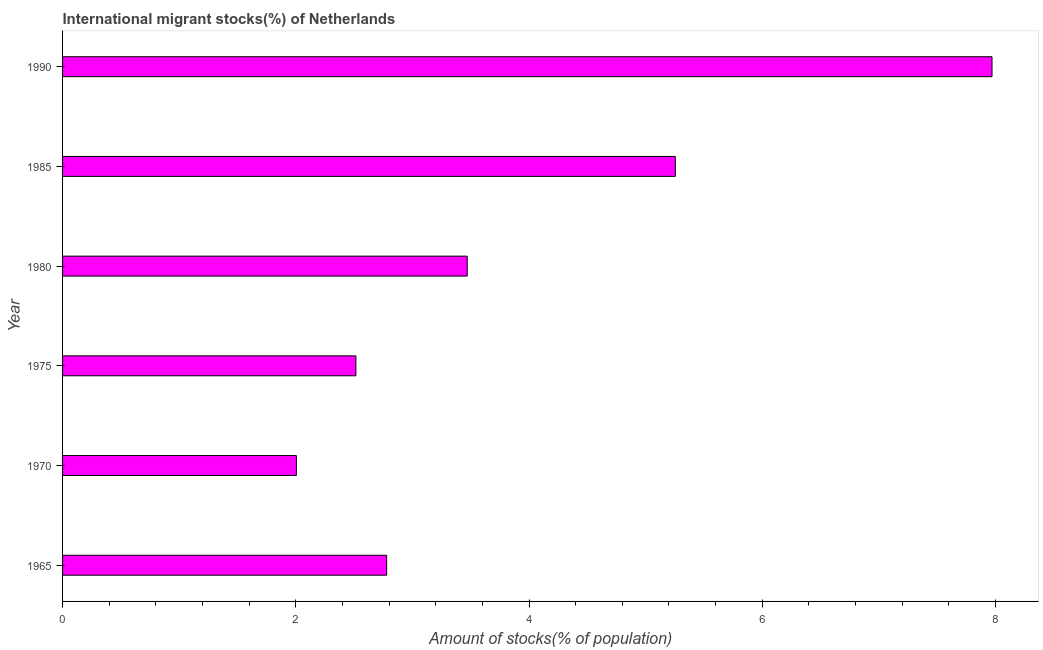Does the graph contain any zero values?
Provide a short and direct response. No. What is the title of the graph?
Make the answer very short. International migrant stocks(%) of Netherlands. What is the label or title of the X-axis?
Keep it short and to the point. Amount of stocks(% of population). What is the label or title of the Y-axis?
Ensure brevity in your answer.  Year. What is the number of international migrant stocks in 1980?
Your answer should be very brief. 3.47. Across all years, what is the maximum number of international migrant stocks?
Provide a succinct answer. 7.97. Across all years, what is the minimum number of international migrant stocks?
Your answer should be compact. 2. In which year was the number of international migrant stocks maximum?
Your answer should be compact. 1990. What is the sum of the number of international migrant stocks?
Keep it short and to the point. 23.99. What is the difference between the number of international migrant stocks in 1965 and 1990?
Your answer should be very brief. -5.19. What is the average number of international migrant stocks per year?
Provide a succinct answer. 4. What is the median number of international migrant stocks?
Make the answer very short. 3.12. In how many years, is the number of international migrant stocks greater than 2.4 %?
Give a very brief answer. 5. What is the ratio of the number of international migrant stocks in 1965 to that in 1980?
Make the answer very short. 0.8. Is the difference between the number of international migrant stocks in 1985 and 1990 greater than the difference between any two years?
Ensure brevity in your answer.  No. What is the difference between the highest and the second highest number of international migrant stocks?
Your answer should be compact. 2.72. Is the sum of the number of international migrant stocks in 1965 and 1975 greater than the maximum number of international migrant stocks across all years?
Make the answer very short. No. What is the difference between the highest and the lowest number of international migrant stocks?
Your response must be concise. 5.97. What is the Amount of stocks(% of population) in 1965?
Your answer should be very brief. 2.78. What is the Amount of stocks(% of population) of 1970?
Offer a terse response. 2. What is the Amount of stocks(% of population) of 1975?
Offer a very short reply. 2.52. What is the Amount of stocks(% of population) in 1980?
Offer a very short reply. 3.47. What is the Amount of stocks(% of population) in 1985?
Provide a short and direct response. 5.25. What is the Amount of stocks(% of population) in 1990?
Your answer should be very brief. 7.97. What is the difference between the Amount of stocks(% of population) in 1965 and 1970?
Provide a succinct answer. 0.77. What is the difference between the Amount of stocks(% of population) in 1965 and 1975?
Offer a terse response. 0.26. What is the difference between the Amount of stocks(% of population) in 1965 and 1980?
Provide a succinct answer. -0.69. What is the difference between the Amount of stocks(% of population) in 1965 and 1985?
Your answer should be compact. -2.48. What is the difference between the Amount of stocks(% of population) in 1965 and 1990?
Your answer should be compact. -5.19. What is the difference between the Amount of stocks(% of population) in 1970 and 1975?
Provide a succinct answer. -0.51. What is the difference between the Amount of stocks(% of population) in 1970 and 1980?
Offer a very short reply. -1.47. What is the difference between the Amount of stocks(% of population) in 1970 and 1985?
Provide a short and direct response. -3.25. What is the difference between the Amount of stocks(% of population) in 1970 and 1990?
Ensure brevity in your answer.  -5.97. What is the difference between the Amount of stocks(% of population) in 1975 and 1980?
Provide a short and direct response. -0.95. What is the difference between the Amount of stocks(% of population) in 1975 and 1985?
Keep it short and to the point. -2.74. What is the difference between the Amount of stocks(% of population) in 1975 and 1990?
Ensure brevity in your answer.  -5.45. What is the difference between the Amount of stocks(% of population) in 1980 and 1985?
Offer a terse response. -1.78. What is the difference between the Amount of stocks(% of population) in 1980 and 1990?
Offer a terse response. -4.5. What is the difference between the Amount of stocks(% of population) in 1985 and 1990?
Make the answer very short. -2.72. What is the ratio of the Amount of stocks(% of population) in 1965 to that in 1970?
Offer a terse response. 1.39. What is the ratio of the Amount of stocks(% of population) in 1965 to that in 1975?
Offer a very short reply. 1.1. What is the ratio of the Amount of stocks(% of population) in 1965 to that in 1980?
Your answer should be very brief. 0.8. What is the ratio of the Amount of stocks(% of population) in 1965 to that in 1985?
Ensure brevity in your answer.  0.53. What is the ratio of the Amount of stocks(% of population) in 1965 to that in 1990?
Your answer should be very brief. 0.35. What is the ratio of the Amount of stocks(% of population) in 1970 to that in 1975?
Keep it short and to the point. 0.8. What is the ratio of the Amount of stocks(% of population) in 1970 to that in 1980?
Make the answer very short. 0.58. What is the ratio of the Amount of stocks(% of population) in 1970 to that in 1985?
Give a very brief answer. 0.38. What is the ratio of the Amount of stocks(% of population) in 1970 to that in 1990?
Give a very brief answer. 0.25. What is the ratio of the Amount of stocks(% of population) in 1975 to that in 1980?
Keep it short and to the point. 0.72. What is the ratio of the Amount of stocks(% of population) in 1975 to that in 1985?
Provide a succinct answer. 0.48. What is the ratio of the Amount of stocks(% of population) in 1975 to that in 1990?
Offer a very short reply. 0.32. What is the ratio of the Amount of stocks(% of population) in 1980 to that in 1985?
Your response must be concise. 0.66. What is the ratio of the Amount of stocks(% of population) in 1980 to that in 1990?
Your response must be concise. 0.43. What is the ratio of the Amount of stocks(% of population) in 1985 to that in 1990?
Your response must be concise. 0.66. 